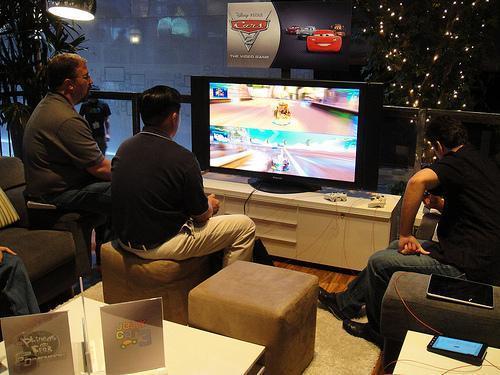How many men are there?
Give a very brief answer. 3. 